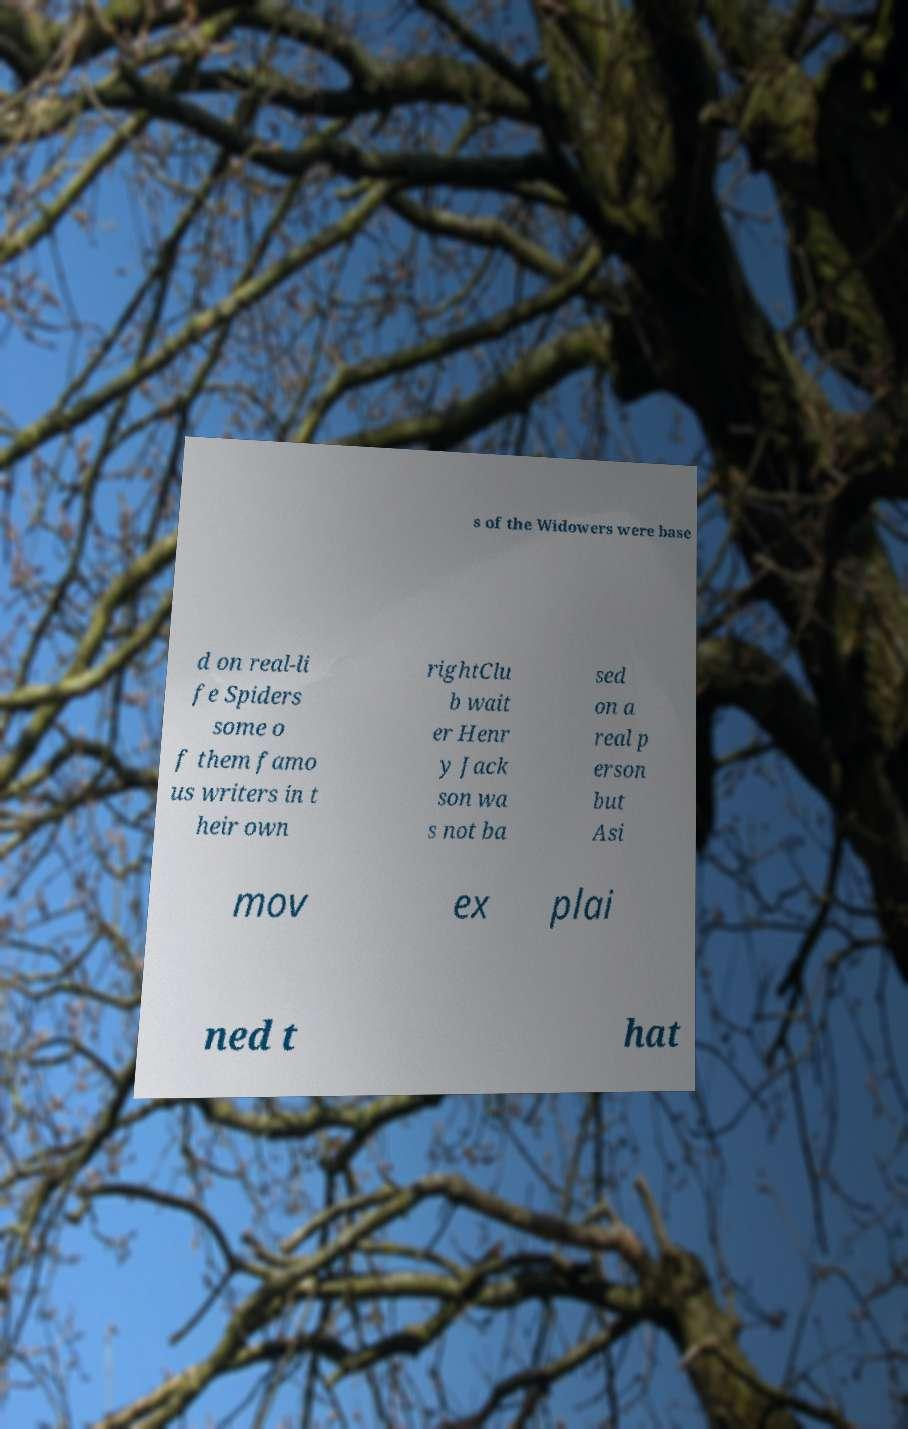What messages or text are displayed in this image? I need them in a readable, typed format. s of the Widowers were base d on real-li fe Spiders some o f them famo us writers in t heir own rightClu b wait er Henr y Jack son wa s not ba sed on a real p erson but Asi mov ex plai ned t hat 